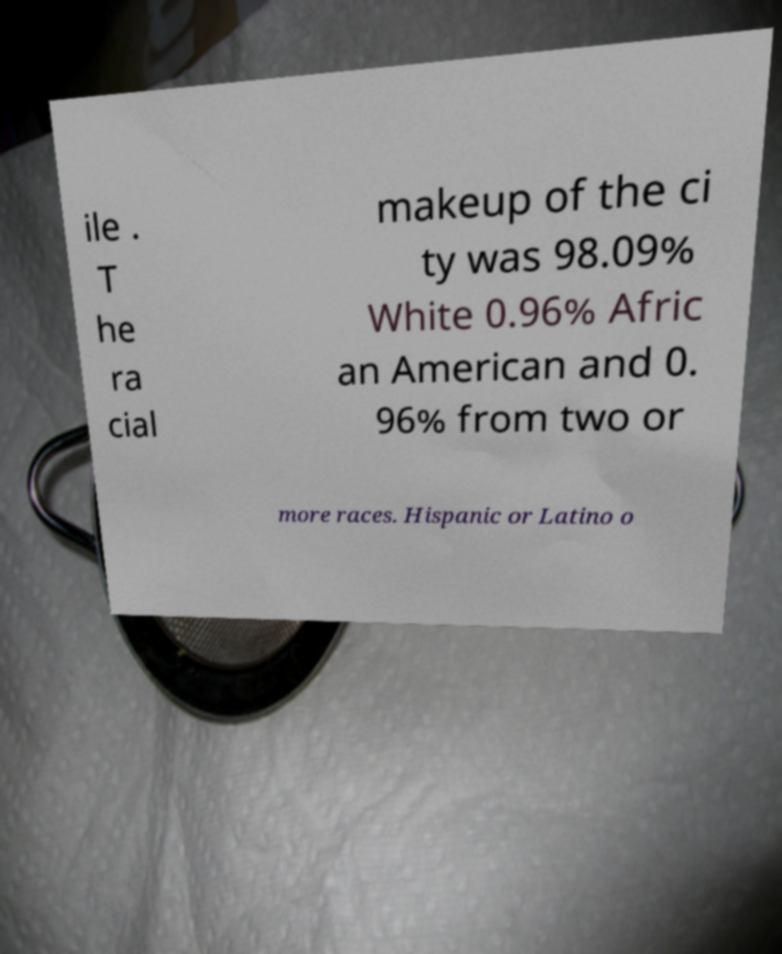There's text embedded in this image that I need extracted. Can you transcribe it verbatim? ile . T he ra cial makeup of the ci ty was 98.09% White 0.96% Afric an American and 0. 96% from two or more races. Hispanic or Latino o 